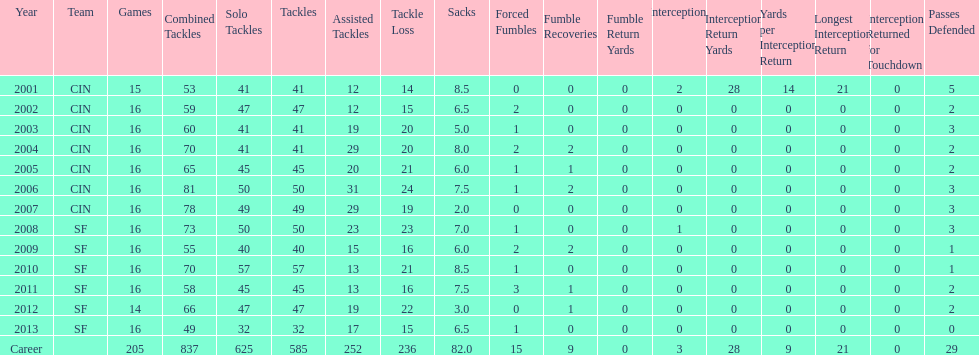What is the average number of tackles this player has had over his career? 45. 